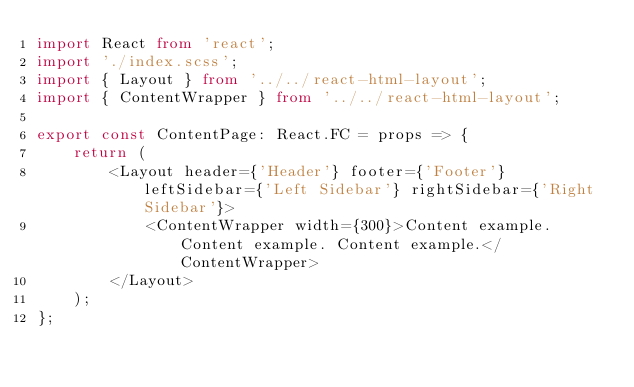Convert code to text. <code><loc_0><loc_0><loc_500><loc_500><_TypeScript_>import React from 'react';
import './index.scss';
import { Layout } from '../../react-html-layout';
import { ContentWrapper } from '../../react-html-layout';

export const ContentPage: React.FC = props => {
    return (
        <Layout header={'Header'} footer={'Footer'} leftSidebar={'Left Sidebar'} rightSidebar={'Right Sidebar'}>
            <ContentWrapper width={300}>Content example. Content example. Content example.</ContentWrapper>
        </Layout>
    );
};
</code> 